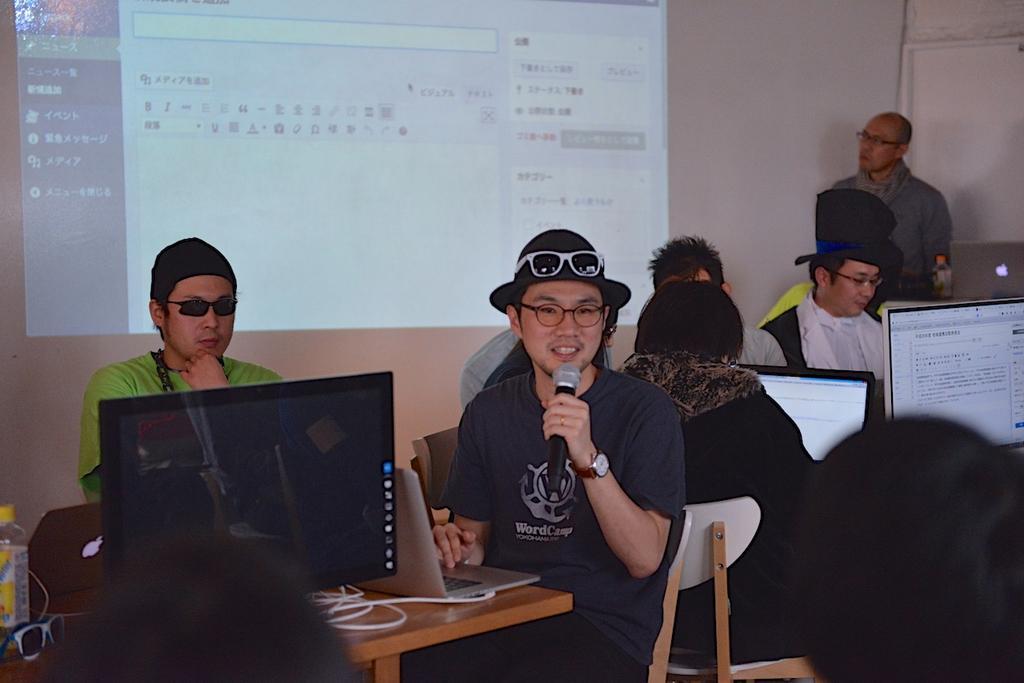Please provide a concise description of this image. As we can see in the image there is a white color wall, screen, few people sitting on chairs and tables. On tables there are laptops. On the left side there is bottle and spectacles 